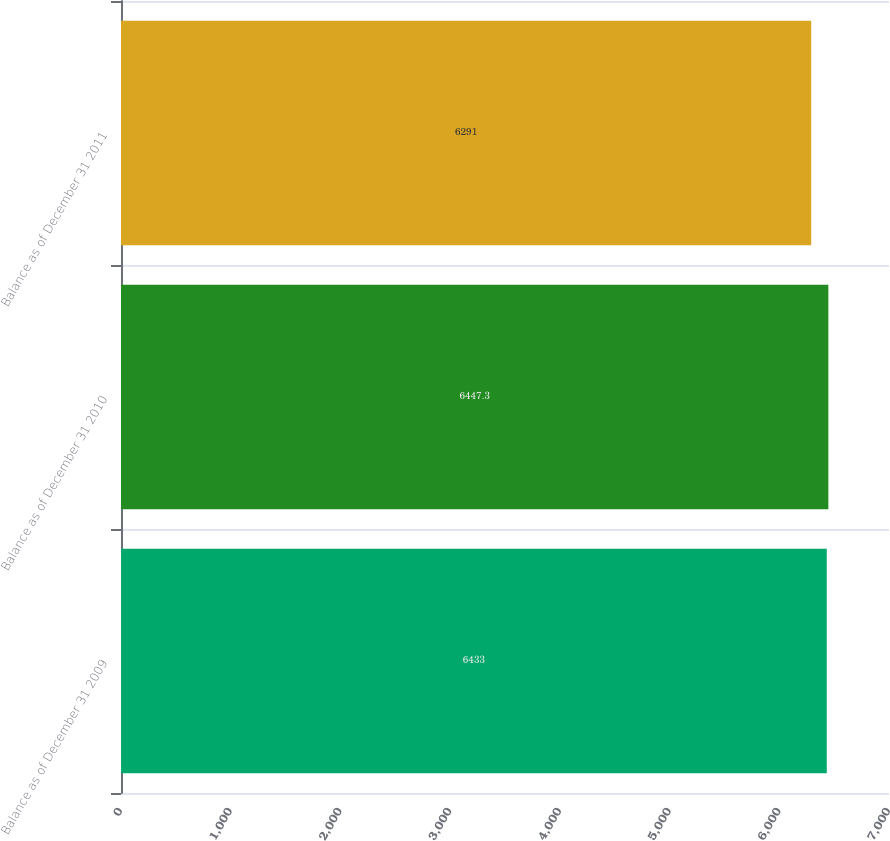Convert chart. <chart><loc_0><loc_0><loc_500><loc_500><bar_chart><fcel>Balance as of December 31 2009<fcel>Balance as of December 31 2010<fcel>Balance as of December 31 2011<nl><fcel>6433<fcel>6447.3<fcel>6291<nl></chart> 